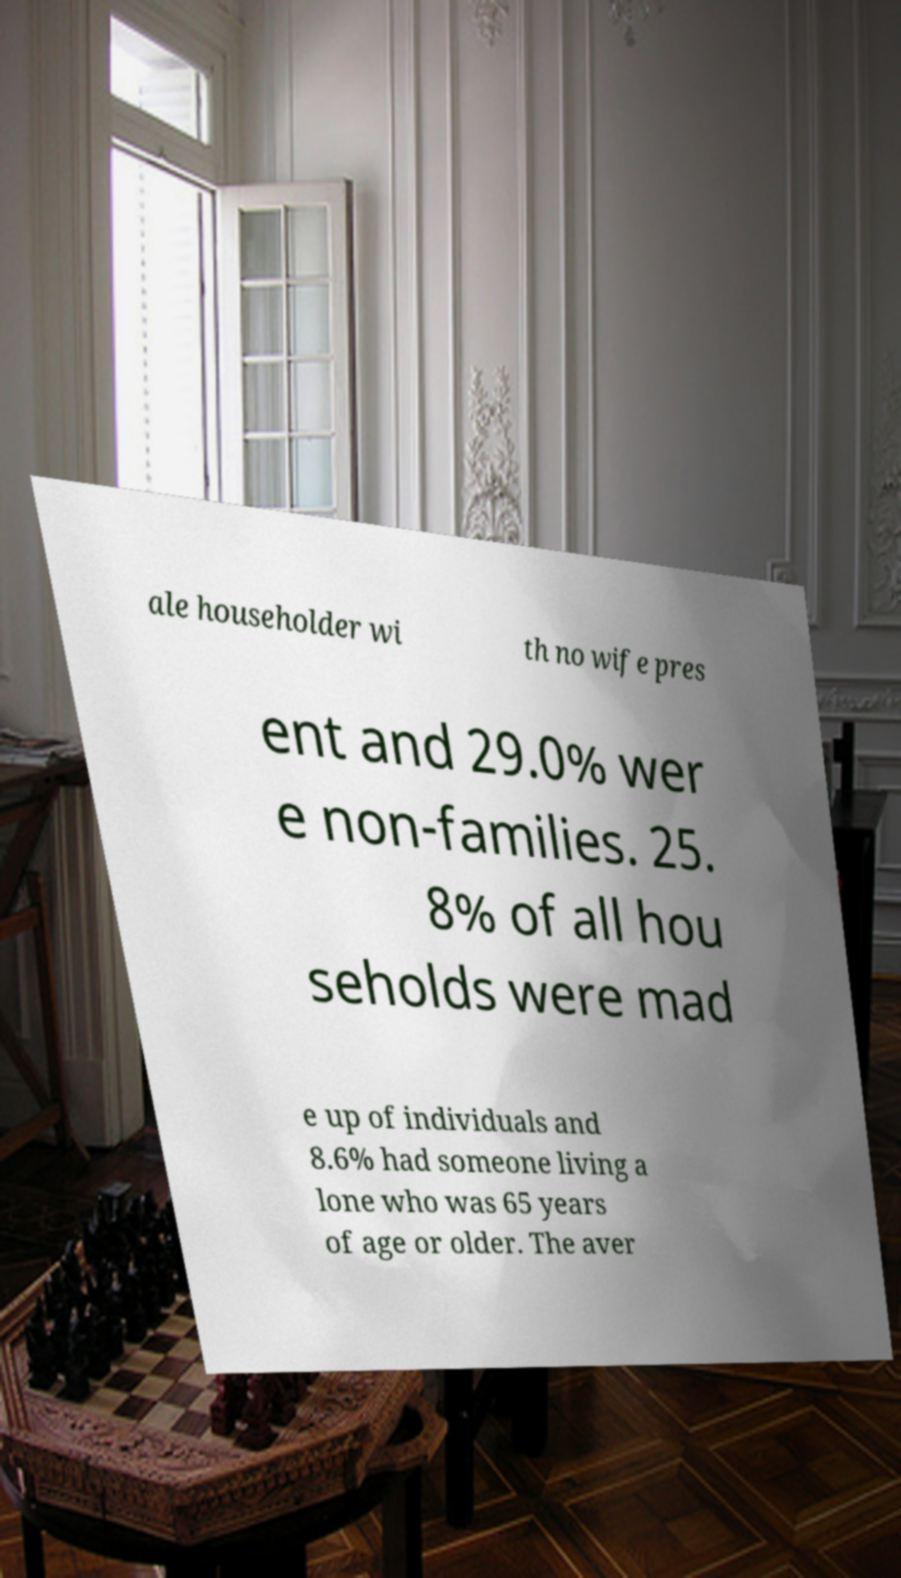What messages or text are displayed in this image? I need them in a readable, typed format. ale householder wi th no wife pres ent and 29.0% wer e non-families. 25. 8% of all hou seholds were mad e up of individuals and 8.6% had someone living a lone who was 65 years of age or older. The aver 